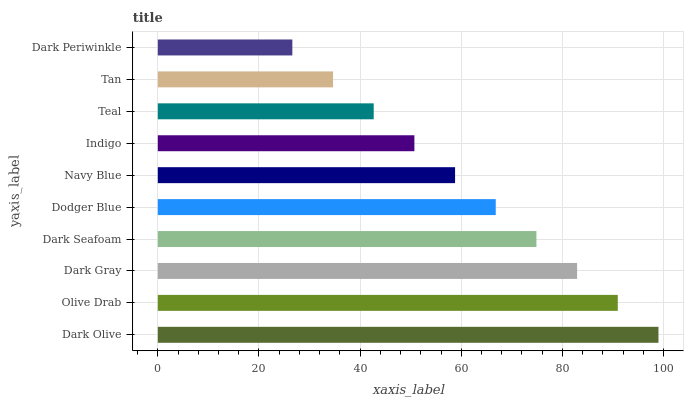Is Dark Periwinkle the minimum?
Answer yes or no. Yes. Is Dark Olive the maximum?
Answer yes or no. Yes. Is Olive Drab the minimum?
Answer yes or no. No. Is Olive Drab the maximum?
Answer yes or no. No. Is Dark Olive greater than Olive Drab?
Answer yes or no. Yes. Is Olive Drab less than Dark Olive?
Answer yes or no. Yes. Is Olive Drab greater than Dark Olive?
Answer yes or no. No. Is Dark Olive less than Olive Drab?
Answer yes or no. No. Is Dodger Blue the high median?
Answer yes or no. Yes. Is Navy Blue the low median?
Answer yes or no. Yes. Is Navy Blue the high median?
Answer yes or no. No. Is Dark Periwinkle the low median?
Answer yes or no. No. 